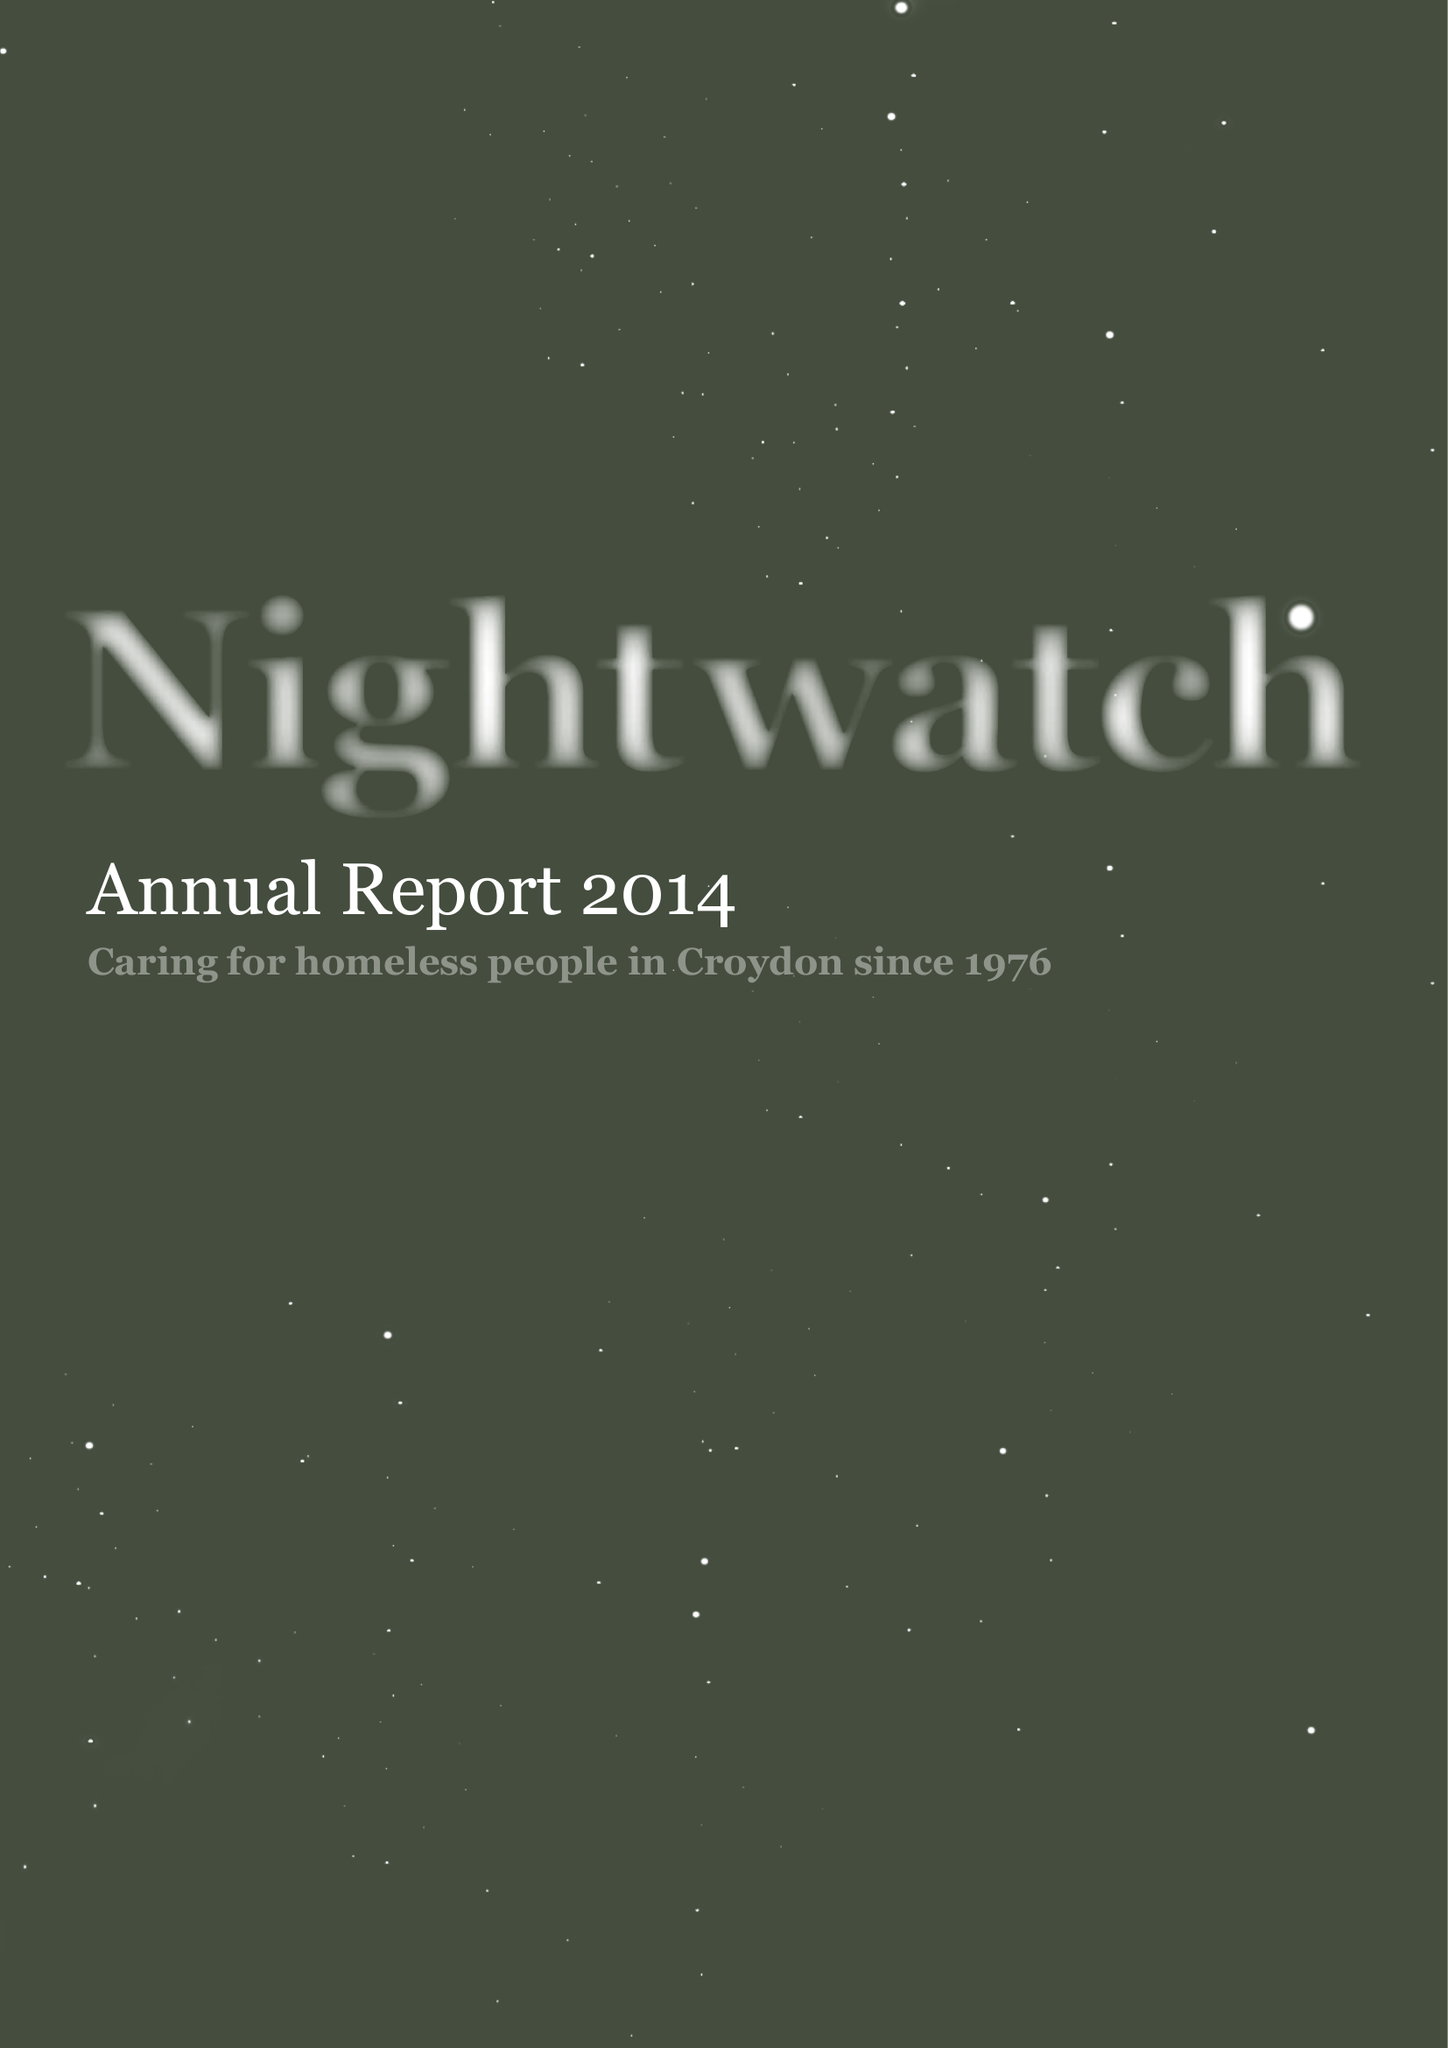What is the value for the income_annually_in_british_pounds?
Answer the question using a single word or phrase. 59234.00 